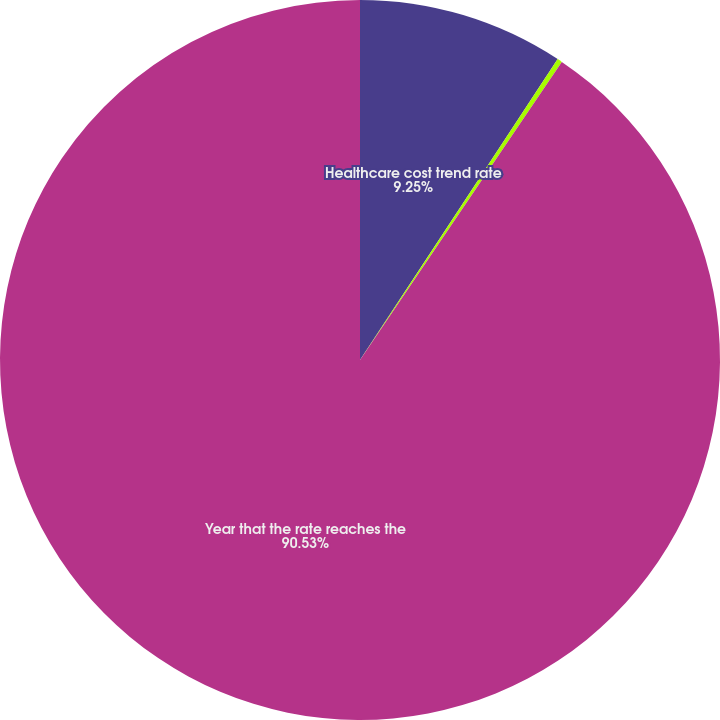<chart> <loc_0><loc_0><loc_500><loc_500><pie_chart><fcel>Healthcare cost trend rate<fcel>Ultimate rate to which the<fcel>Year that the rate reaches the<nl><fcel>9.25%<fcel>0.22%<fcel>90.52%<nl></chart> 